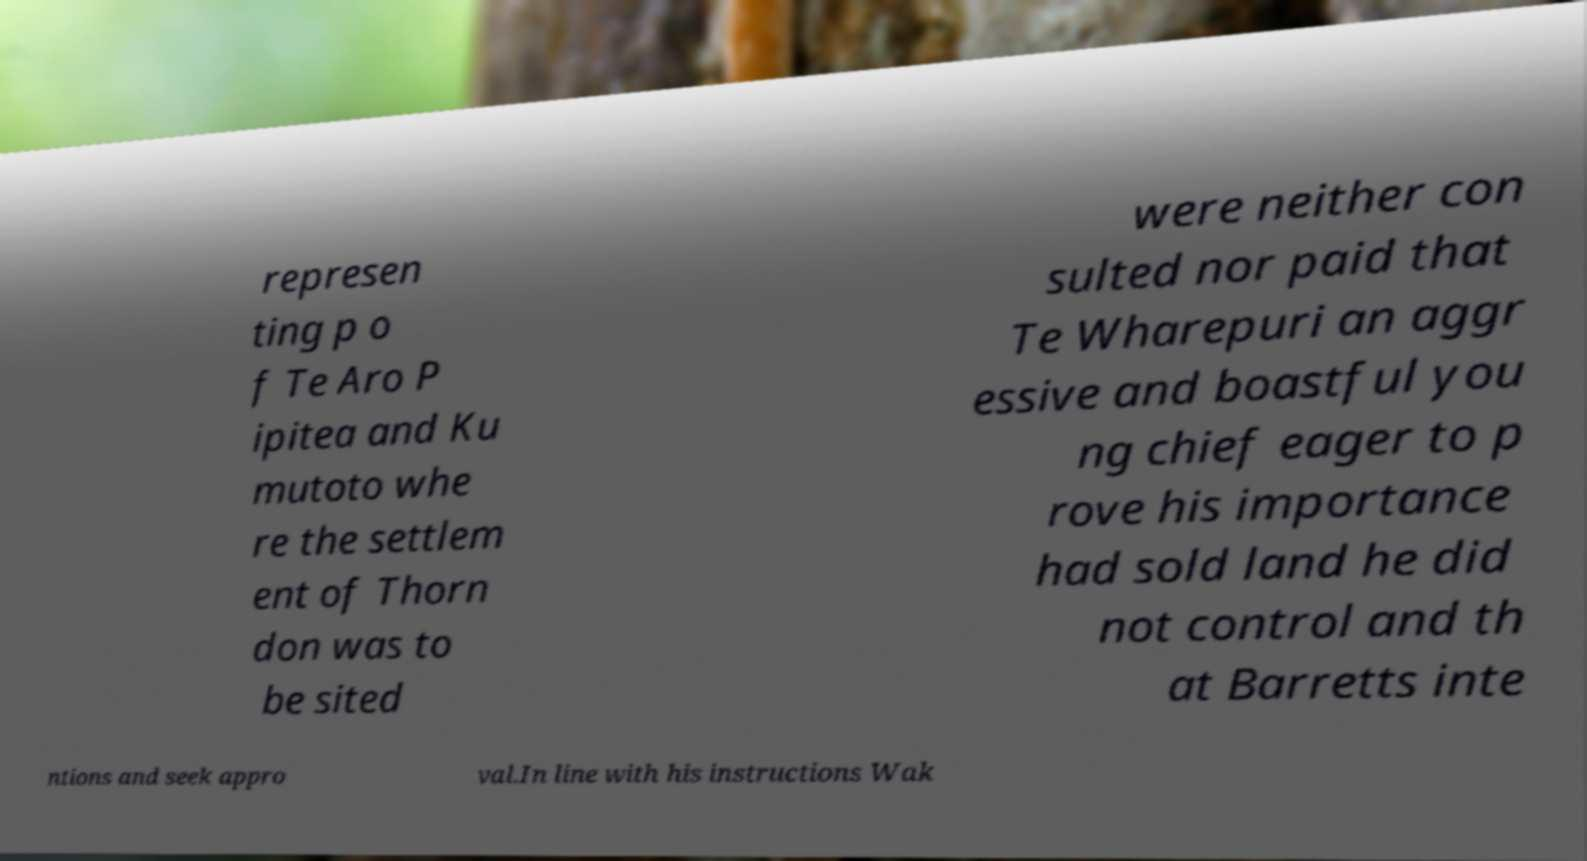Please read and relay the text visible in this image. What does it say? represen ting p o f Te Aro P ipitea and Ku mutoto whe re the settlem ent of Thorn don was to be sited were neither con sulted nor paid that Te Wharepuri an aggr essive and boastful you ng chief eager to p rove his importance had sold land he did not control and th at Barretts inte ntions and seek appro val.In line with his instructions Wak 